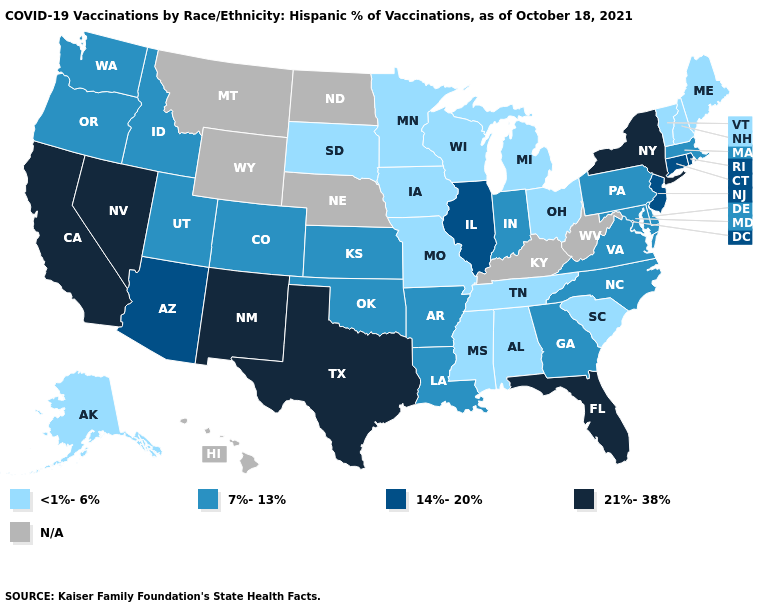Does New Jersey have the highest value in the Northeast?
Be succinct. No. What is the value of Indiana?
Answer briefly. 7%-13%. Name the states that have a value in the range 21%-38%?
Be succinct. California, Florida, Nevada, New Mexico, New York, Texas. Does Tennessee have the highest value in the USA?
Give a very brief answer. No. What is the highest value in states that border Kentucky?
Quick response, please. 14%-20%. Name the states that have a value in the range N/A?
Short answer required. Hawaii, Kentucky, Montana, Nebraska, North Dakota, West Virginia, Wyoming. What is the value of North Carolina?
Write a very short answer. 7%-13%. Which states have the lowest value in the USA?
Give a very brief answer. Alabama, Alaska, Iowa, Maine, Michigan, Minnesota, Mississippi, Missouri, New Hampshire, Ohio, South Carolina, South Dakota, Tennessee, Vermont, Wisconsin. Name the states that have a value in the range <1%-6%?
Write a very short answer. Alabama, Alaska, Iowa, Maine, Michigan, Minnesota, Mississippi, Missouri, New Hampshire, Ohio, South Carolina, South Dakota, Tennessee, Vermont, Wisconsin. Does the map have missing data?
Answer briefly. Yes. Name the states that have a value in the range <1%-6%?
Write a very short answer. Alabama, Alaska, Iowa, Maine, Michigan, Minnesota, Mississippi, Missouri, New Hampshire, Ohio, South Carolina, South Dakota, Tennessee, Vermont, Wisconsin. Among the states that border Massachusetts , does New York have the highest value?
Quick response, please. Yes. 